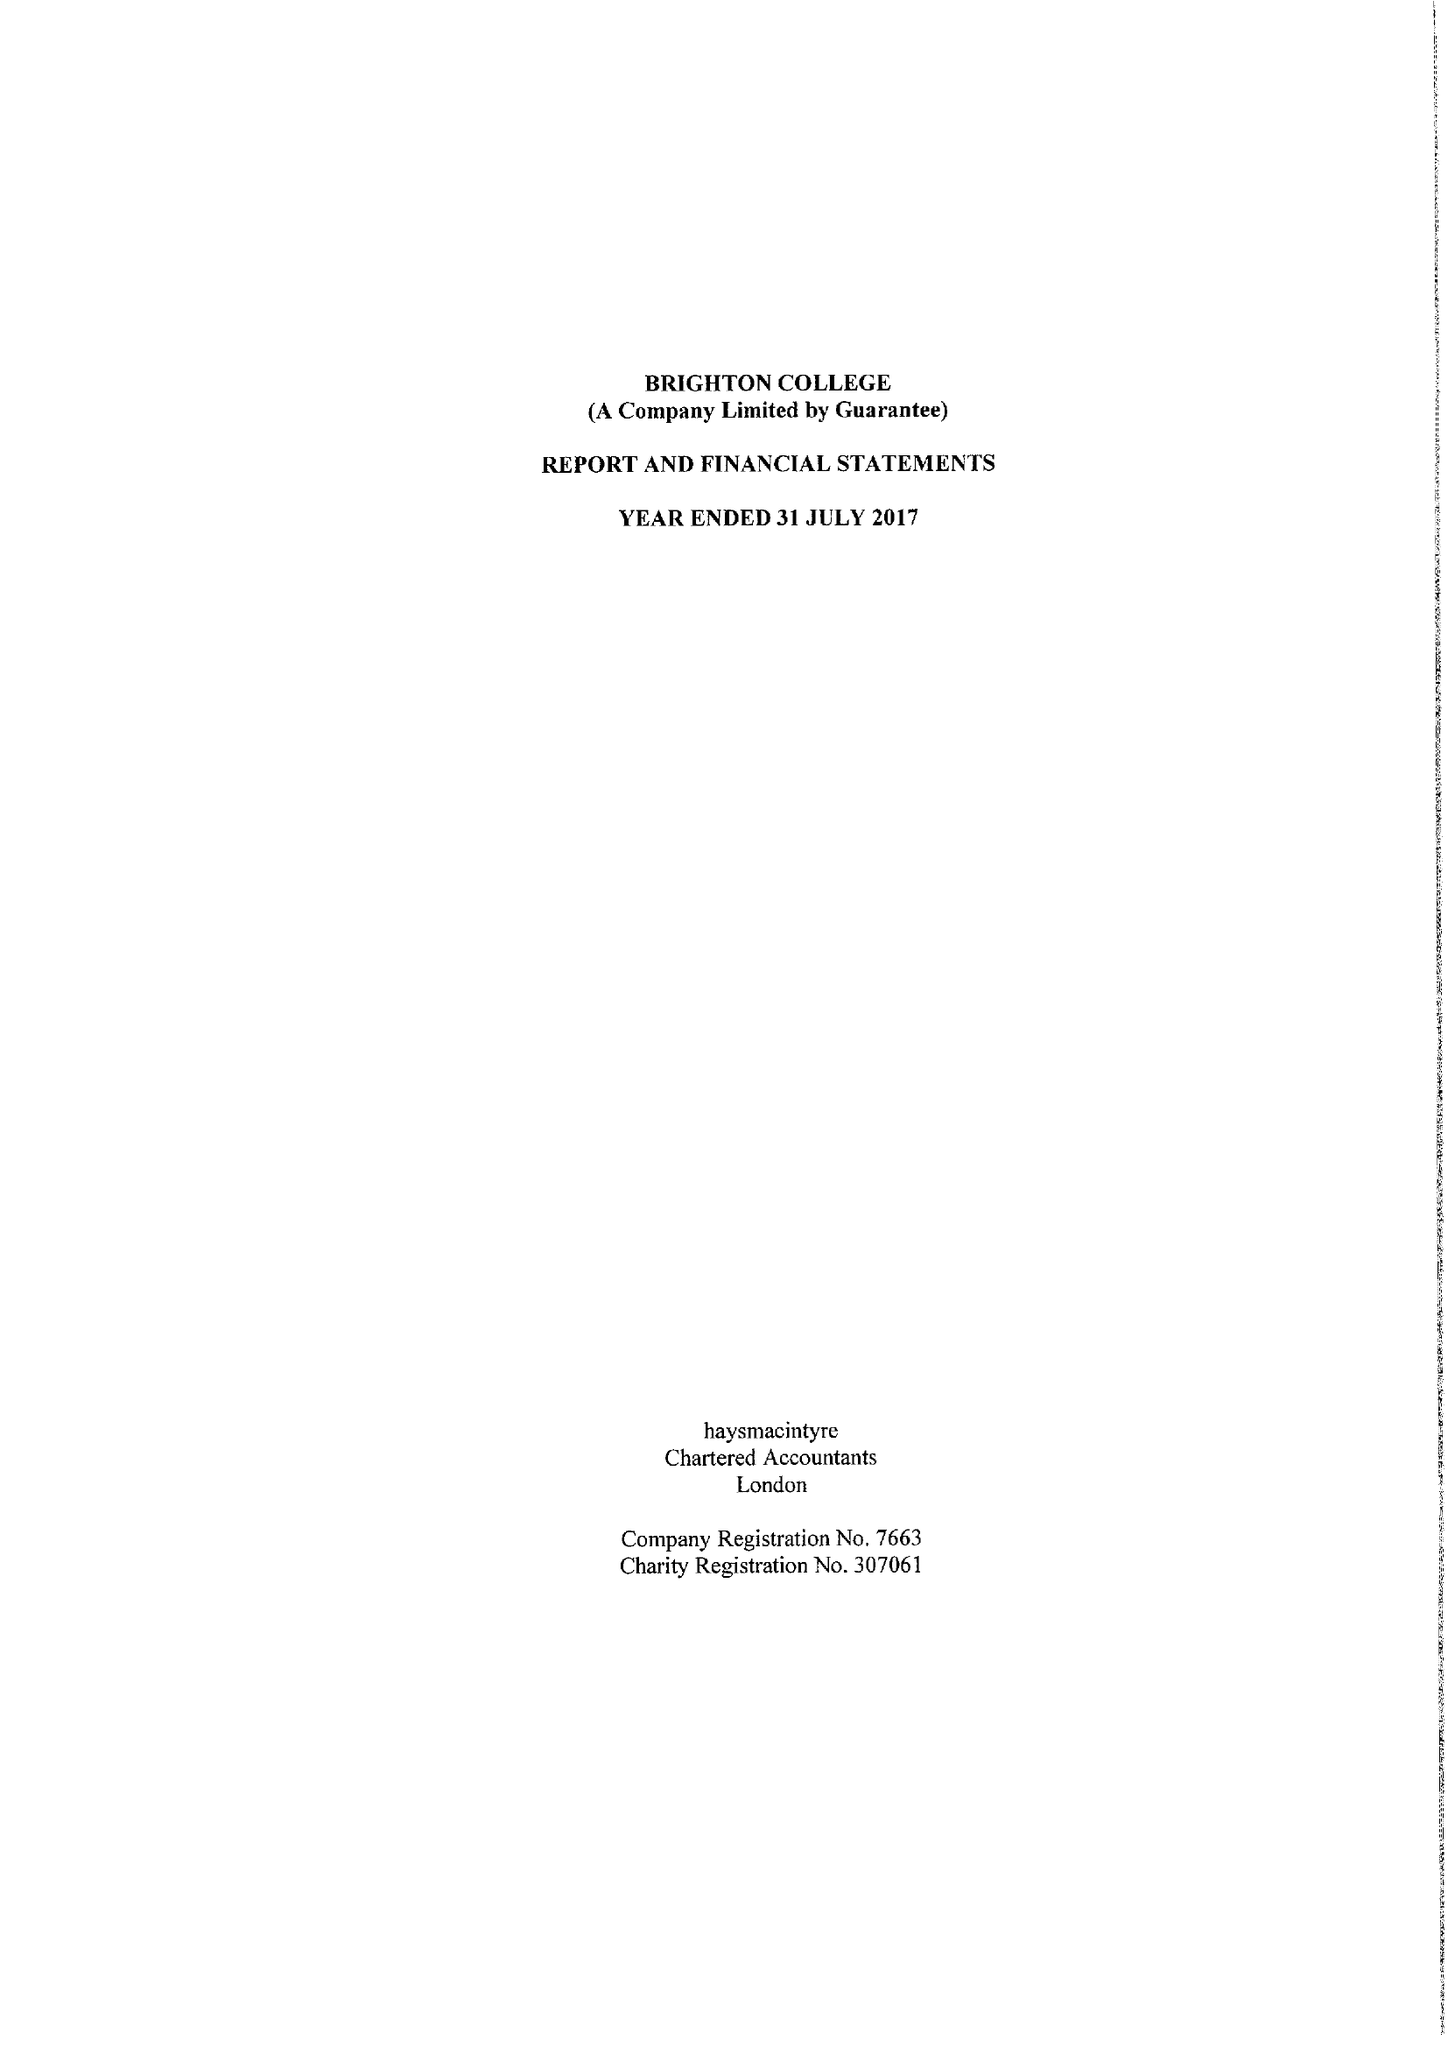What is the value for the address__post_town?
Answer the question using a single word or phrase. BRIGHTON 